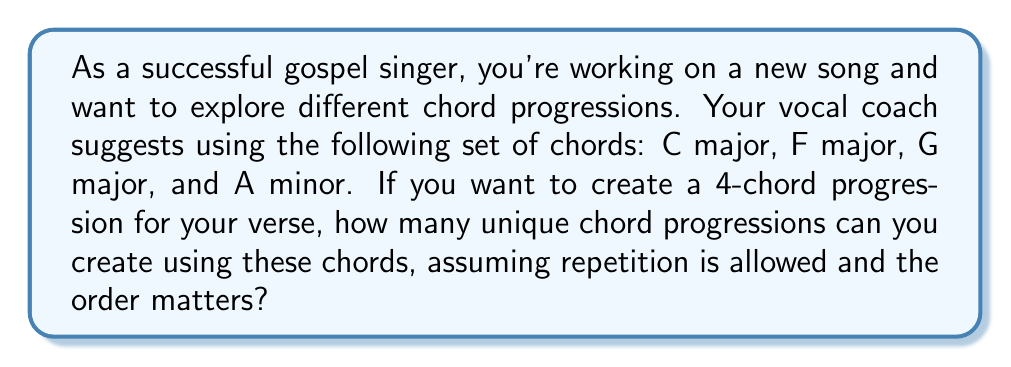Help me with this question. To solve this problem, we need to use the concept of permutations with repetition. Here's how we can break it down:

1. We have 4 chords to choose from: C major, F major, G major, and A minor.
2. We need to create a 4-chord progression.
3. We can use any chord multiple times (repetition is allowed).
4. The order of the chords matters (e.g., C-F-G-Am is different from F-C-G-Am).

This scenario is a perfect example of permutations with repetition. The formula for this is:

$$ n^r $$

Where:
$n$ = number of choices for each position
$r$ = number of positions to be filled

In our case:
$n = 4$ (4 chords to choose from)
$r = 4$ (4 positions in the progression)

Therefore, the number of possible chord progressions is:

$$ 4^4 = 4 \times 4 \times 4 \times 4 = 256 $$

This means you have 256 unique ways to arrange these 4 chords into a 4-chord progression for your verse.
Answer: 256 unique chord progressions 